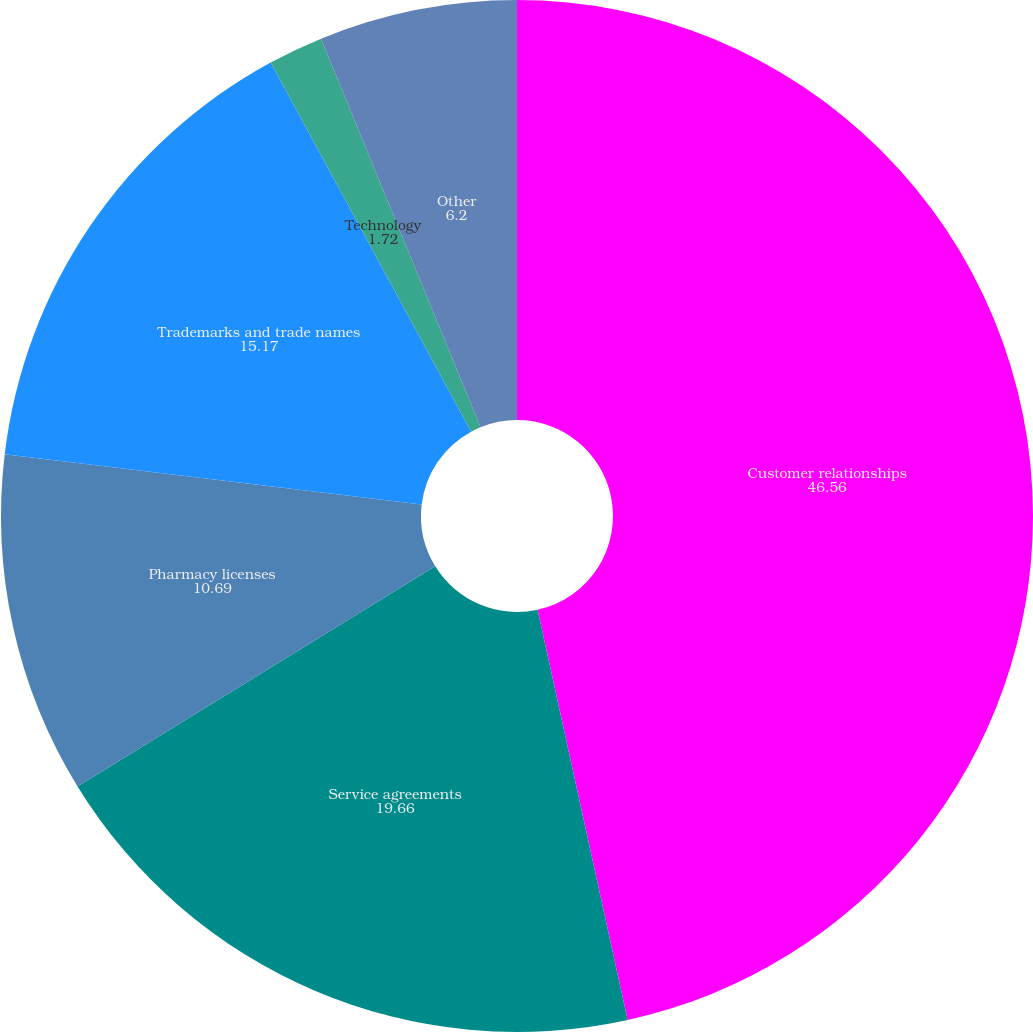Convert chart to OTSL. <chart><loc_0><loc_0><loc_500><loc_500><pie_chart><fcel>Customer relationships<fcel>Service agreements<fcel>Pharmacy licenses<fcel>Trademarks and trade names<fcel>Technology<fcel>Other<nl><fcel>46.56%<fcel>19.66%<fcel>10.69%<fcel>15.17%<fcel>1.72%<fcel>6.2%<nl></chart> 